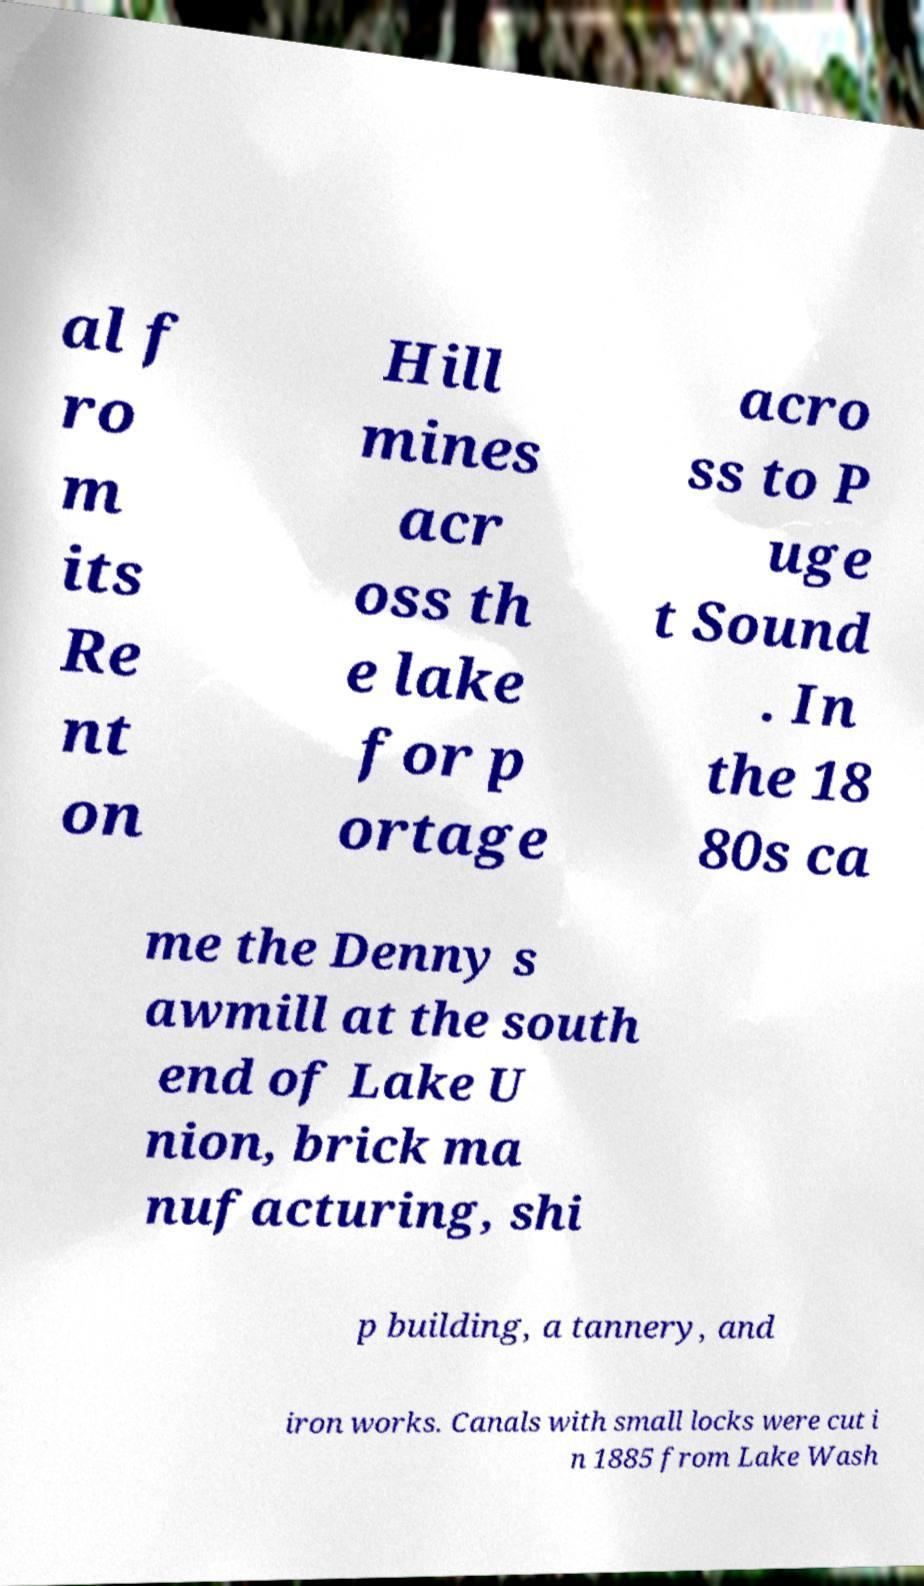I need the written content from this picture converted into text. Can you do that? al f ro m its Re nt on Hill mines acr oss th e lake for p ortage acro ss to P uge t Sound . In the 18 80s ca me the Denny s awmill at the south end of Lake U nion, brick ma nufacturing, shi p building, a tannery, and iron works. Canals with small locks were cut i n 1885 from Lake Wash 